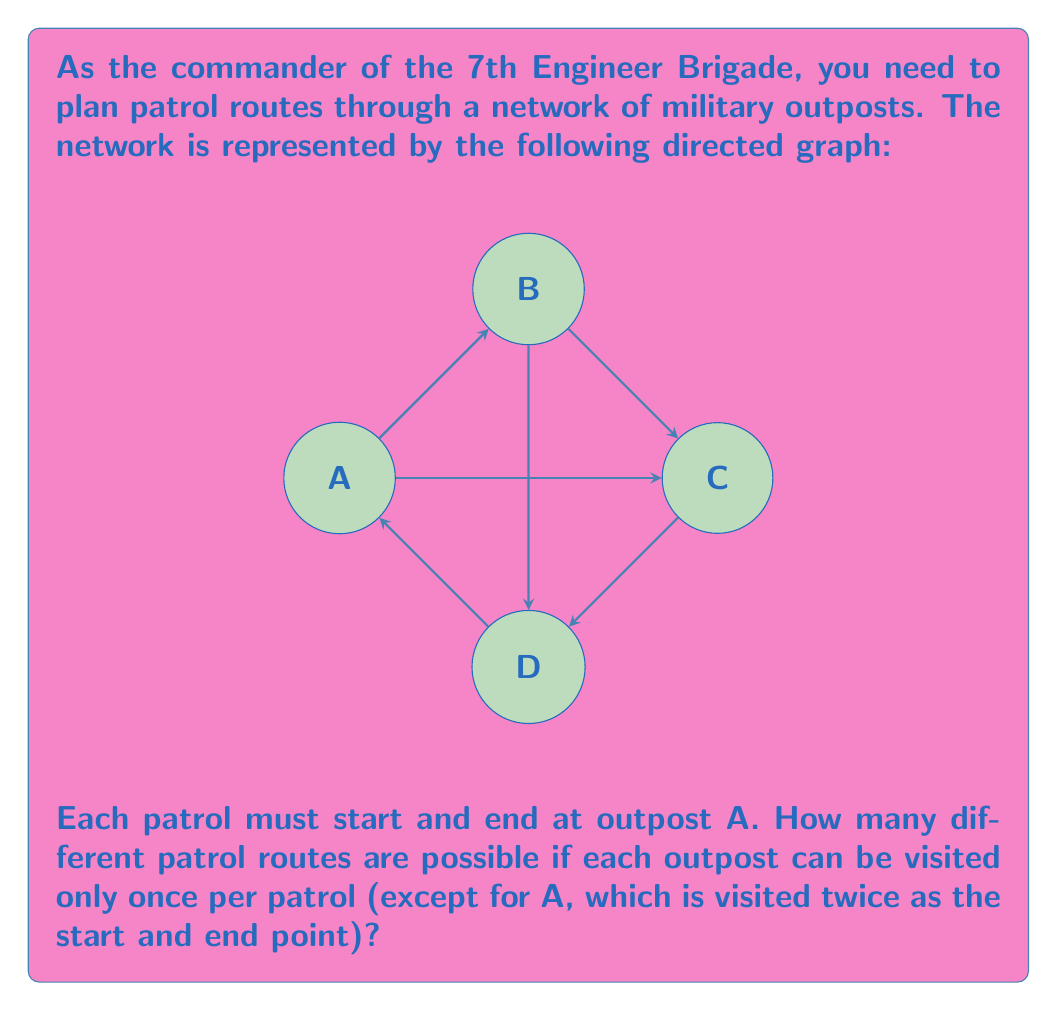Solve this math problem. Let's approach this step-by-step:

1) First, we need to recognize that this is a problem of counting Hamiltonian cycles in a directed graph. A Hamiltonian cycle is a cycle that visits each vertex exactly once, except for the starting vertex which is also the ending vertex.

2) We can solve this using the following method:
   a) Start at A
   b) Choose one of the possible next outposts
   c) Continue until we've visited all outposts
   d) Return to A

3) Let's count the possibilities:
   
   - From A, we have 3 choices: B, C, or D
   
   - If we choose B:
     * We must then go to either C or D
     * If we go to C, we must then go to D and back to A
     * If we go to D, we must then go to C and back to A
     So there are 2 routes starting A-B
   
   - If we choose C:
     * We must then go to either B or D
     * If we go to B, we must then go to D and back to A
     * If we go to D, we must then go to B and back to A
     So there are 2 routes starting A-C
   
   - If we choose D:
     * We must then go to either B or C
     * If we go to B, we must then go to C and back to A
     * If we go to C, we must then go to B and back to A
     So there are 2 routes starting A-D

4) Therefore, the total number of possible routes is:
   
   $$2 + 2 + 2 = 6$$

Thus, there are 6 different possible patrol routes.
Answer: 6 routes 